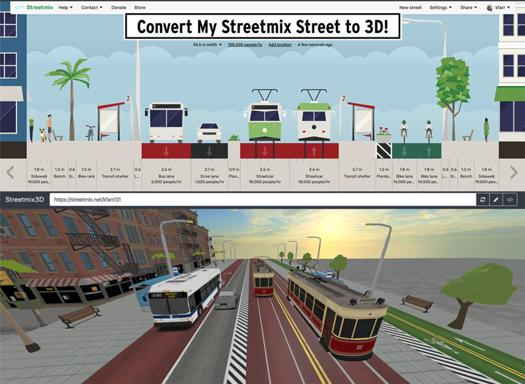Describe the screenshot of the city in the image. The screenshot displays a detailed and bustling urban setting with multiple transportation options, including a bus and a tram, which highlight the city’s efficient and diverse transit system. The realistic depiction also suggests the software's capability in providing a vivid and practical visualization of urban planning designs. 